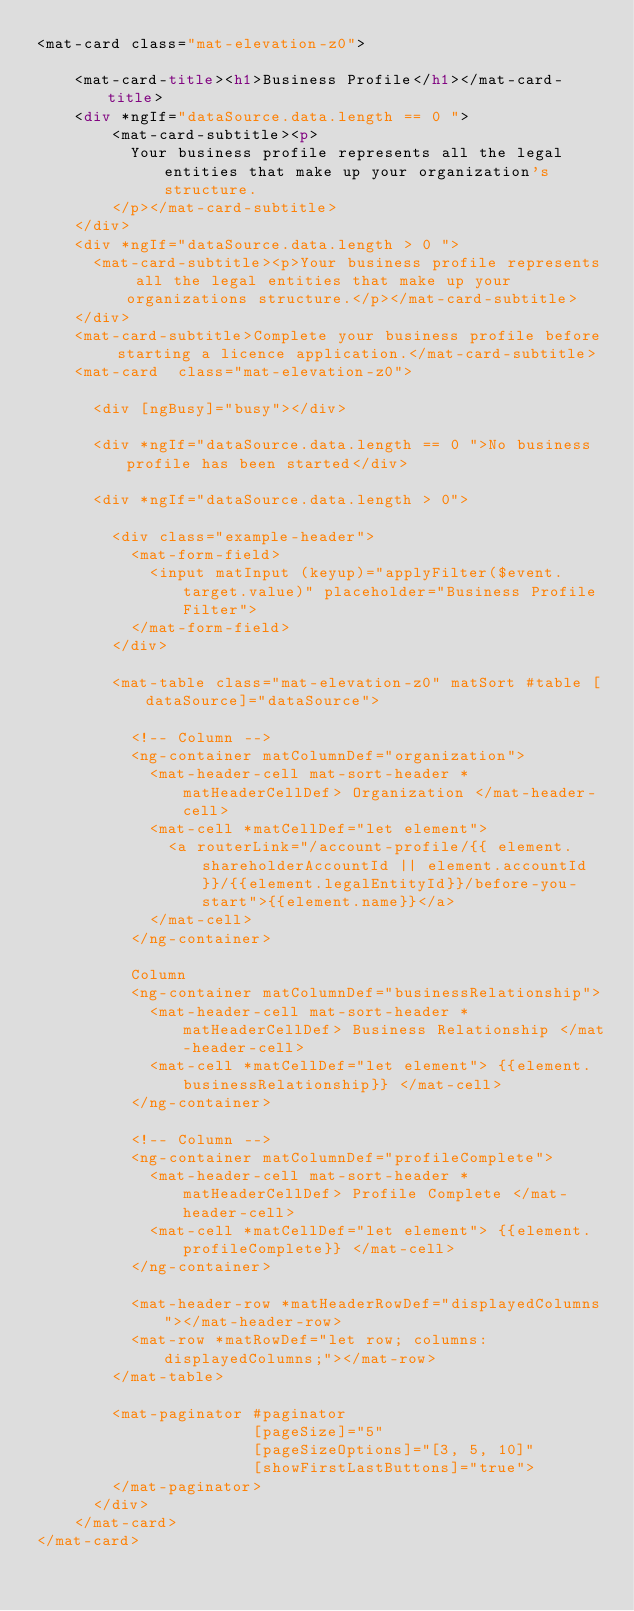Convert code to text. <code><loc_0><loc_0><loc_500><loc_500><_HTML_><mat-card class="mat-elevation-z0">

    <mat-card-title><h1>Business Profile</h1></mat-card-title>
    <div *ngIf="dataSource.data.length == 0 ">
        <mat-card-subtitle><p>
          Your business profile represents all the legal entities that make up your organization's structure.
        </p></mat-card-subtitle>
    </div>
    <div *ngIf="dataSource.data.length > 0 ">
      <mat-card-subtitle><p>Your business profile represents all the legal entities that make up your organizations structure.</p></mat-card-subtitle>
    </div>
    <mat-card-subtitle>Complete your business profile before starting a licence application.</mat-card-subtitle>
    <mat-card  class="mat-elevation-z0">

      <div [ngBusy]="busy"></div>

      <div *ngIf="dataSource.data.length == 0 ">No business profile has been started</div>

      <div *ngIf="dataSource.data.length > 0">

        <div class="example-header">
          <mat-form-field>
            <input matInput (keyup)="applyFilter($event.target.value)" placeholder="Business Profile Filter">
          </mat-form-field>
        </div>

        <mat-table class="mat-elevation-z0" matSort #table [dataSource]="dataSource">

          <!-- Column -->
          <ng-container matColumnDef="organization">
            <mat-header-cell mat-sort-header *matHeaderCellDef> Organization </mat-header-cell>
            <mat-cell *matCellDef="let element">
              <a routerLink="/account-profile/{{ element.shareholderAccountId || element.accountId}}/{{element.legalEntityId}}/before-you-start">{{element.name}}</a>
            </mat-cell> 
          </ng-container>

          Column
          <ng-container matColumnDef="businessRelationship">
            <mat-header-cell mat-sort-header *matHeaderCellDef> Business Relationship </mat-header-cell>
            <mat-cell *matCellDef="let element"> {{element.businessRelationship}} </mat-cell>
          </ng-container>

          <!-- Column -->
          <ng-container matColumnDef="profileComplete">
            <mat-header-cell mat-sort-header *matHeaderCellDef> Profile Complete </mat-header-cell>
            <mat-cell *matCellDef="let element"> {{element.profileComplete}} </mat-cell>
          </ng-container>

          <mat-header-row *matHeaderRowDef="displayedColumns"></mat-header-row>
          <mat-row *matRowDef="let row; columns: displayedColumns;"></mat-row>
        </mat-table>

        <mat-paginator #paginator
                       [pageSize]="5"
                       [pageSizeOptions]="[3, 5, 10]"
                       [showFirstLastButtons]="true">
        </mat-paginator>
      </div>
    </mat-card>
</mat-card>
</code> 